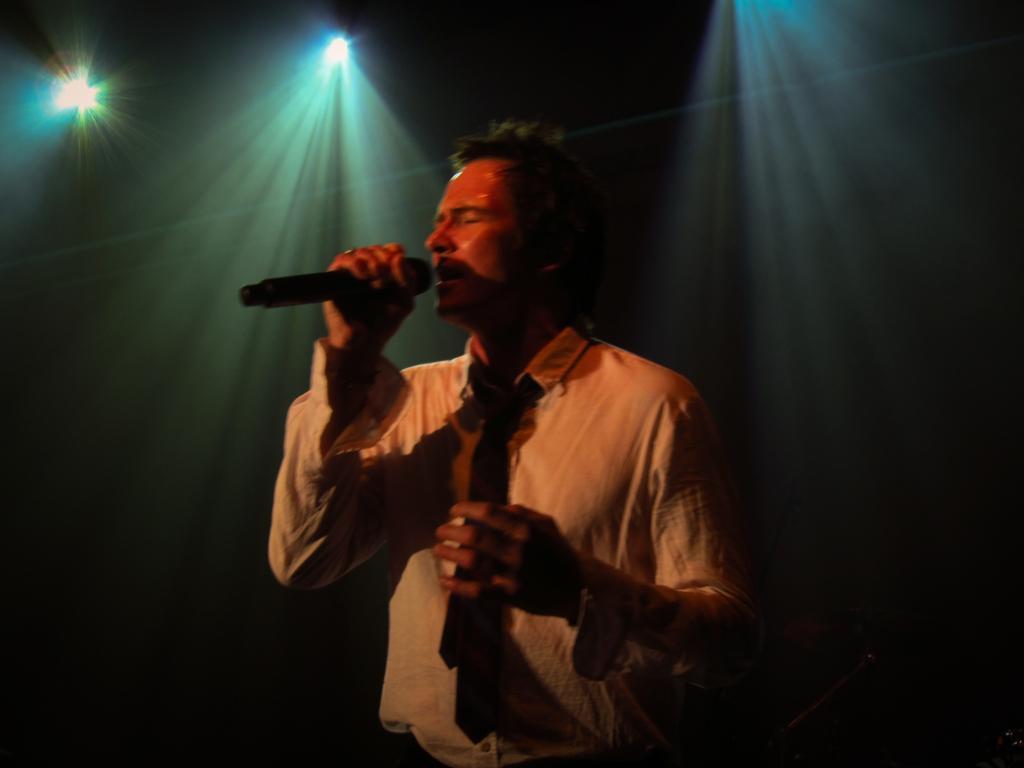Please provide a concise description of this image. Here a man is singing on mic and he is wearing tie on him behind him there are lights. 